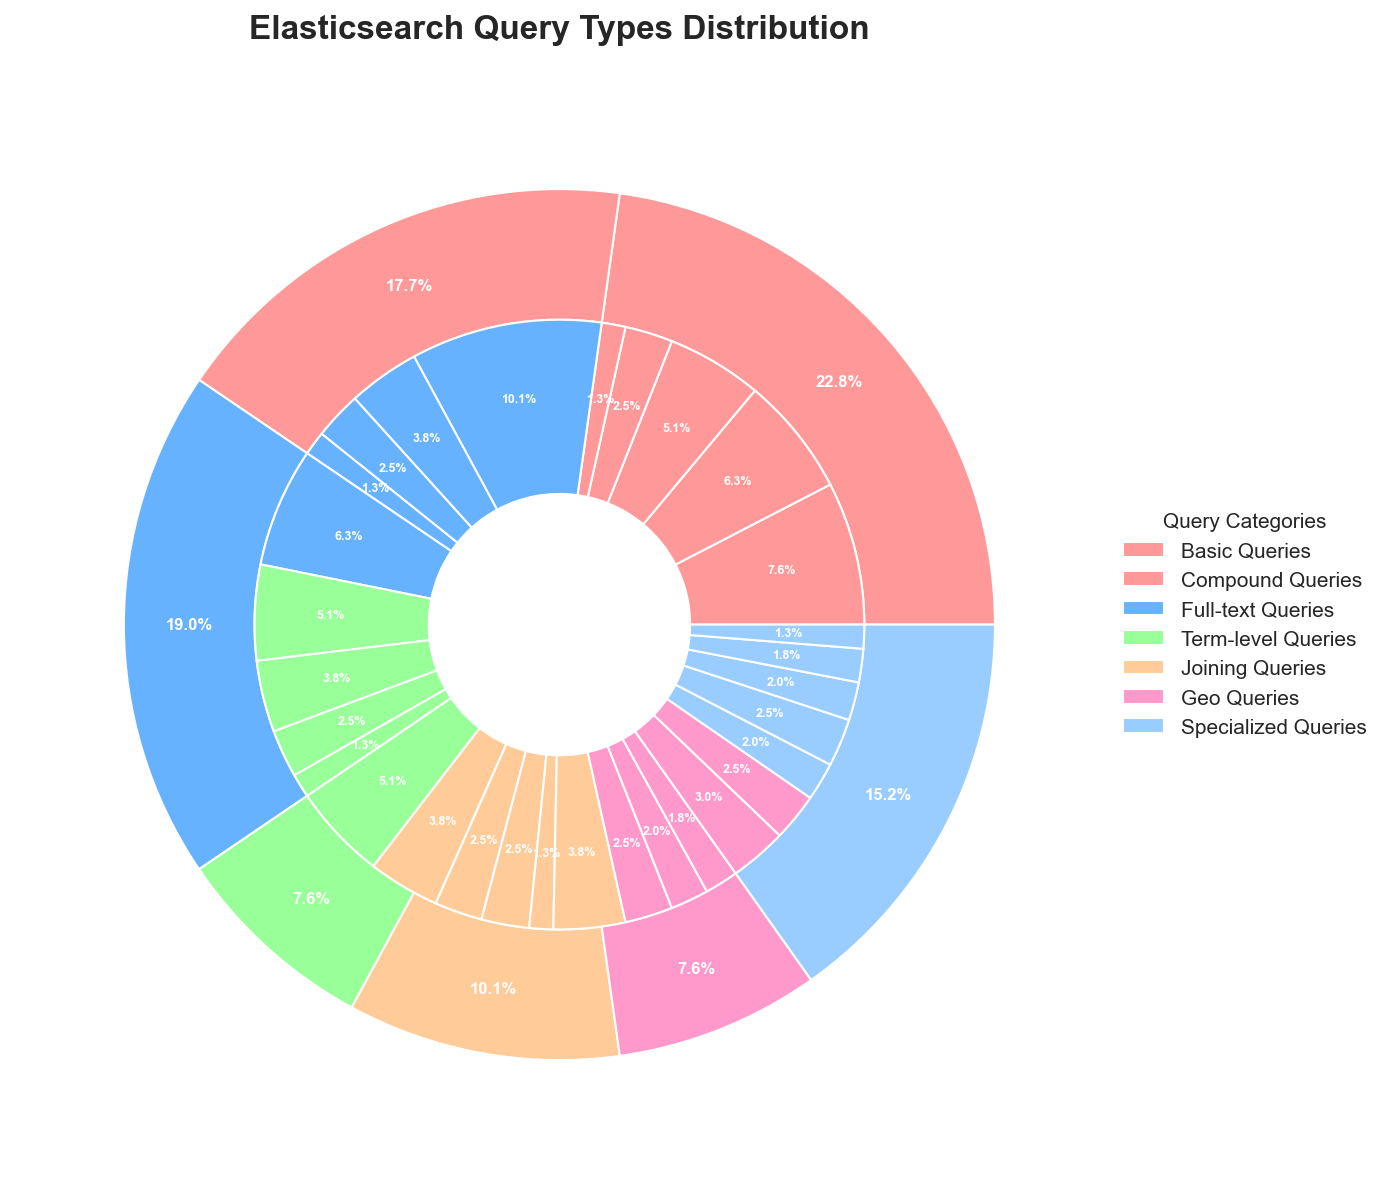What is the largest category in terms of value? The outer pie chart represents different categories, each occupying a distinct segment. The category with the largest segment relative to other segments is 'Compound Queries'.
Answer: Compound Queries What percentage of total queries are Term-level Queries? From the outer pie chart, look for the segment labeled 'Term-level Queries'. The percentage label next to it is the required value.
Answer: 16.7% How do Basic Queries compare with Full-text Queries in terms of their proportion of the whole? The percentages of 'Basic Queries' and 'Full-text Queries' can be read from the outer pie chart. 'Basic Queries' account for 30% while 'Full-text Queries' account for 25%. Therefore, 'Basic Queries' form a larger portion of the whole.
Answer: Basic Queries are larger Which subcategory within Basic Queries has the smallest value? In the inner pie chart, locate the segment corresponding to 'Basic Queries' and then find the smallest segment within this category. The smallest one is labeled 'Prefix'.
Answer: Prefix What is the combined percentage of all Specialized Queries? To find this, locate all segments labeled under 'Specialized Queries' in the outer pie chart. The label for 'Specialized Queries' shows 10%, combining these subcategories.
Answer: 10% Between 'Geo Queries' and 'Joining Queries', which has a higher overall value? From the outer pie chart, compare the segments labeled 'Geo Queries' and 'Joining Queries'. 'Joining Queries' form 13% while 'Geo Queries' form 10%. Therefore, 'Joining Queries' have a higher overall value.
Answer: Joining Queries What percentage of the total are 'Bool' queries within Compound Queries? First, find the percentage of 'Bool' within the 'Compound Queries' segment in the inner pie chart. 'Bool' queries take 40 units out of the total unit measure.
Answer: 40% Which subcategory in Full-text Queries has the highest representation? Within the 'Full-text Queries' category in the inner pie chart, locate the segment with the highest value. 'Multi Match' is the highest.
Answer: Multi Match What is the difference in value between the 'Match' subcategory and the 'Term' subcategory within Basic Queries? 'Match' has a value of 30 and 'Term' has a value of 25. Subtracting the two gives 5.
Answer: 5 How does the proportion of the 'Nested' subcategory in Joining Queries compare to the 'Terms' subcategory in Term-level Queries? 'Nested' in Joining Queries is 15, and 'Terms' in Term-level Queries is 20. By comparing these values directly, 'Terms' in Term-level Queries is larger.
Answer: Terms is larger 